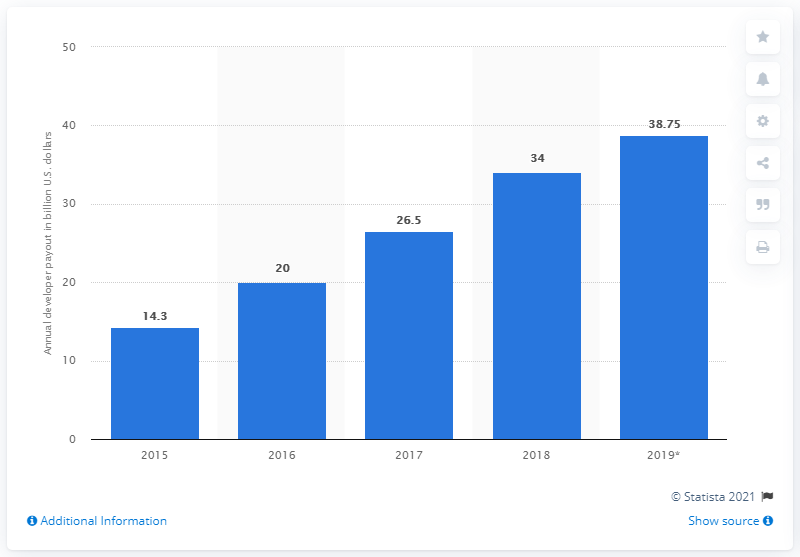List a handful of essential elements in this visual. Apple paid approximately 34 billion US dollars to iOS app developers in the previous year. In 2019, Apple paid a total of 38.75 to iOS app developers. 